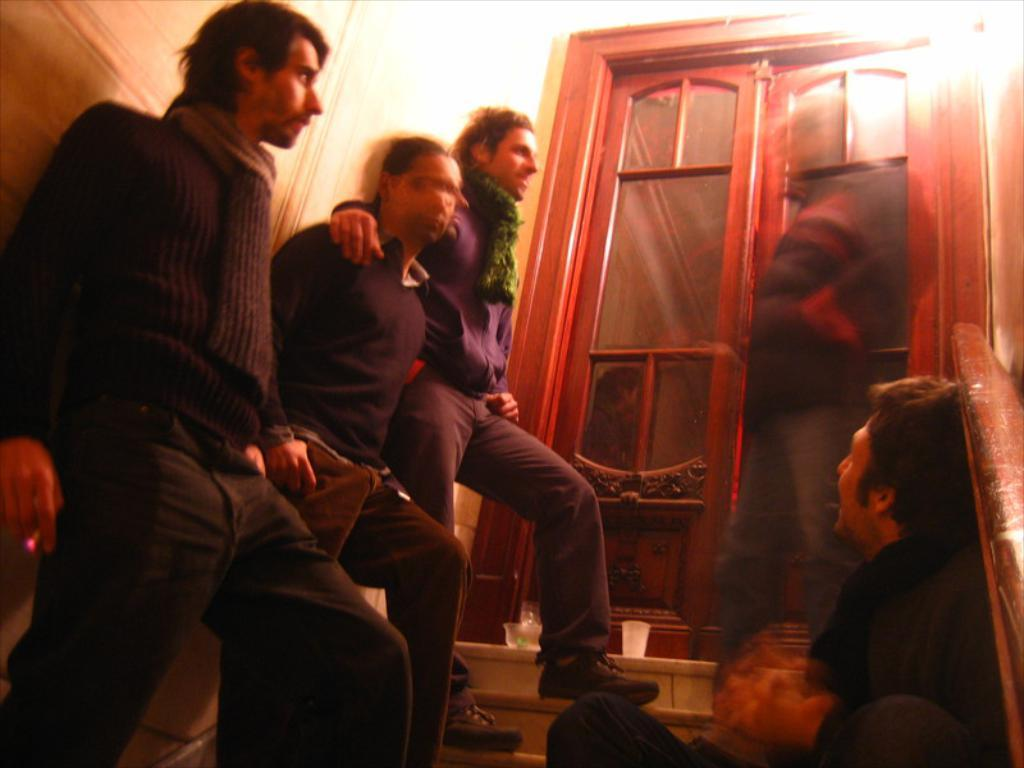How many people are standing on the staircase in the image? There are three persons standing on the staircase on the left side of the image. What can be seen in the middle of the image? There are doors in the middle of the image. What object is located at the bottom of the image? There appears to be a glass at the bottom of the image. What type of sticks are the brothers holding in the image? There are no sticks or brothers present in the image. How much salt is visible on the glass in the image? There is no salt visible on the glass in the image. 